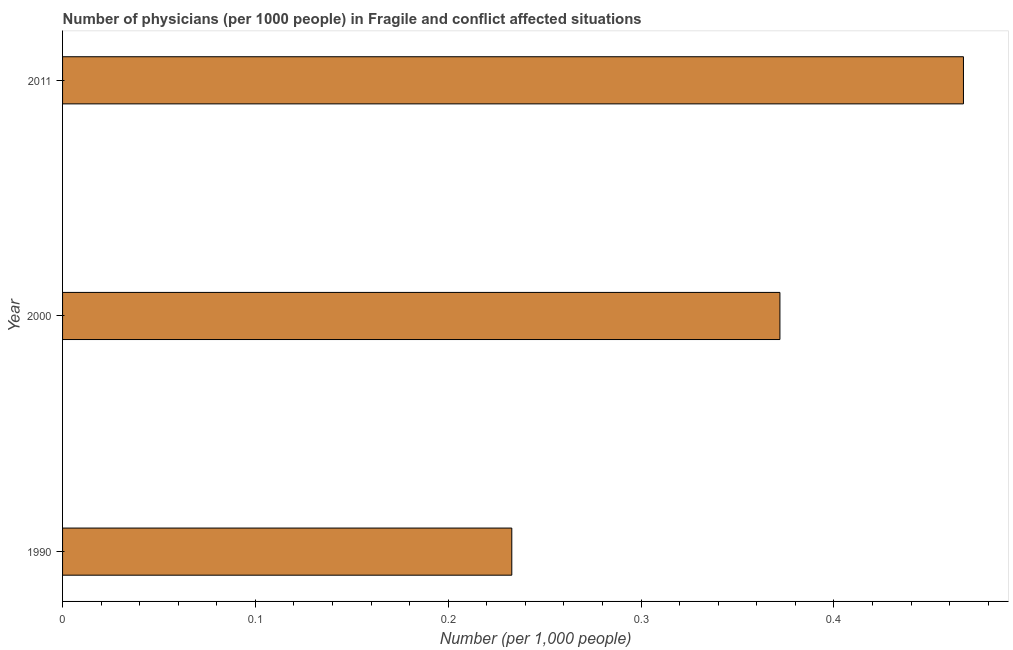What is the title of the graph?
Keep it short and to the point. Number of physicians (per 1000 people) in Fragile and conflict affected situations. What is the label or title of the X-axis?
Ensure brevity in your answer.  Number (per 1,0 people). What is the label or title of the Y-axis?
Ensure brevity in your answer.  Year. What is the number of physicians in 2011?
Your answer should be very brief. 0.47. Across all years, what is the maximum number of physicians?
Provide a succinct answer. 0.47. Across all years, what is the minimum number of physicians?
Provide a short and direct response. 0.23. In which year was the number of physicians maximum?
Your answer should be compact. 2011. In which year was the number of physicians minimum?
Give a very brief answer. 1990. What is the sum of the number of physicians?
Give a very brief answer. 1.07. What is the difference between the number of physicians in 2000 and 2011?
Your response must be concise. -0.1. What is the average number of physicians per year?
Keep it short and to the point. 0.36. What is the median number of physicians?
Your answer should be very brief. 0.37. What is the ratio of the number of physicians in 1990 to that in 2011?
Give a very brief answer. 0.5. What is the difference between the highest and the second highest number of physicians?
Your answer should be compact. 0.1. What is the difference between the highest and the lowest number of physicians?
Provide a succinct answer. 0.23. How many bars are there?
Ensure brevity in your answer.  3. How many years are there in the graph?
Your response must be concise. 3. What is the Number (per 1,000 people) of 1990?
Provide a short and direct response. 0.23. What is the Number (per 1,000 people) of 2000?
Offer a very short reply. 0.37. What is the Number (per 1,000 people) of 2011?
Offer a terse response. 0.47. What is the difference between the Number (per 1,000 people) in 1990 and 2000?
Offer a very short reply. -0.14. What is the difference between the Number (per 1,000 people) in 1990 and 2011?
Keep it short and to the point. -0.23. What is the difference between the Number (per 1,000 people) in 2000 and 2011?
Ensure brevity in your answer.  -0.1. What is the ratio of the Number (per 1,000 people) in 1990 to that in 2000?
Provide a short and direct response. 0.63. What is the ratio of the Number (per 1,000 people) in 1990 to that in 2011?
Offer a terse response. 0.5. What is the ratio of the Number (per 1,000 people) in 2000 to that in 2011?
Provide a short and direct response. 0.8. 